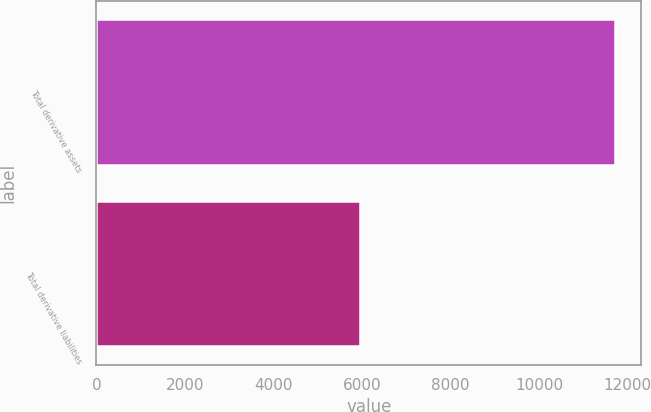<chart> <loc_0><loc_0><loc_500><loc_500><bar_chart><fcel>Total derivative assets<fcel>Total derivative liabilities<nl><fcel>11716<fcel>5945<nl></chart> 